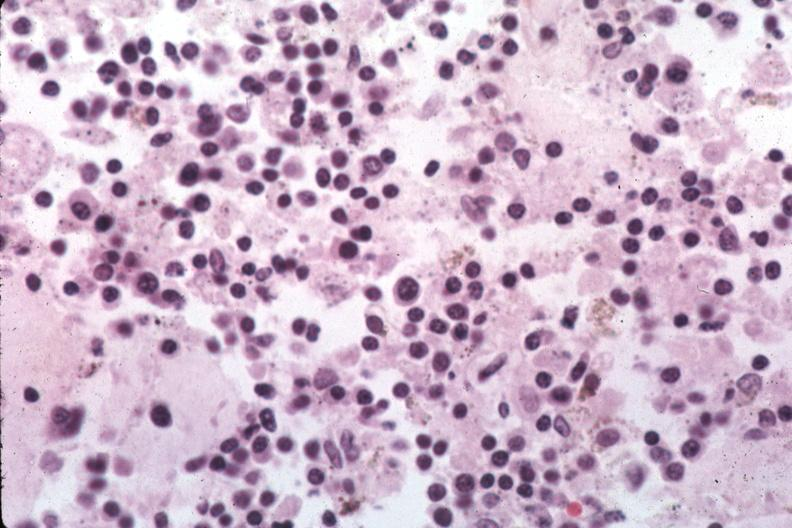does hilar cell tumor show organisms are easily evident?
Answer the question using a single word or phrase. No 